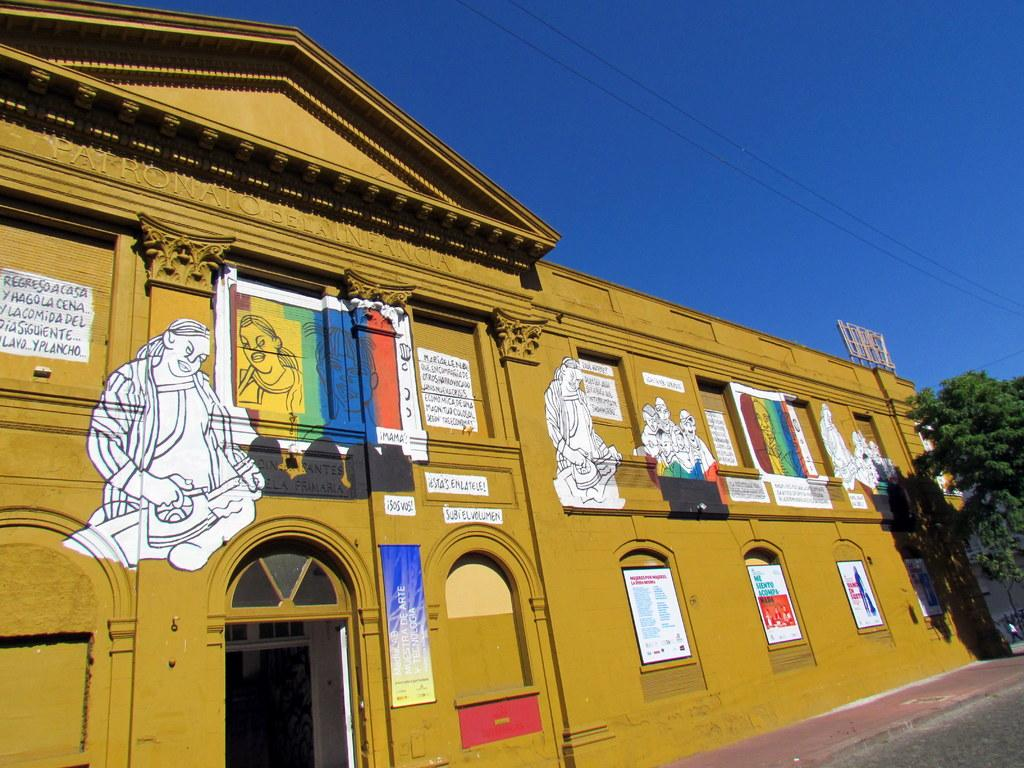What type of structure is visible in the image? There is a building in the image. What can be seen on the building? The building has pictures on it, and there is something written on it. What is located in the right corner of the image? There is a tree in the right corner of the image. What color is the sky in the image? The sky is blue in color. What type of rose is growing on the building in the image? There is no rose present in the image; it features a building with pictures and writing on it. What shape is the crow flying in the image? There is no crow present in the image. 